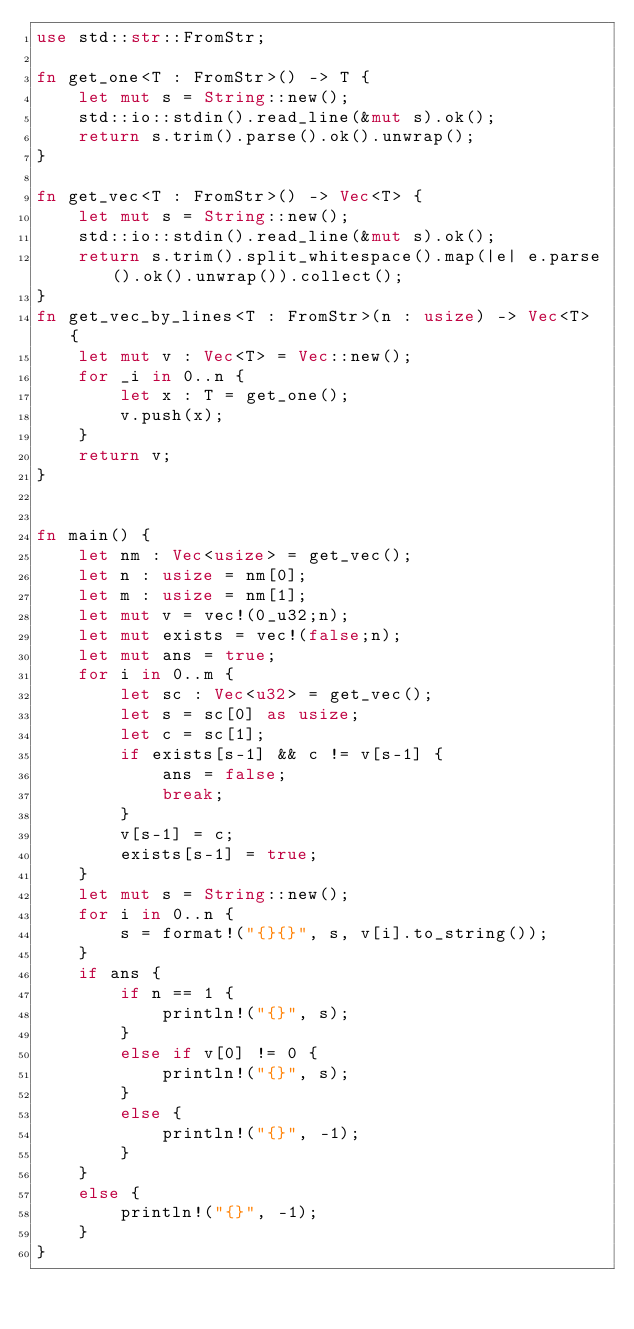Convert code to text. <code><loc_0><loc_0><loc_500><loc_500><_Rust_>use std::str::FromStr;

fn get_one<T : FromStr>() -> T {
    let mut s = String::new();
    std::io::stdin().read_line(&mut s).ok();
    return s.trim().parse().ok().unwrap();
}

fn get_vec<T : FromStr>() -> Vec<T> {
    let mut s = String::new();
    std::io::stdin().read_line(&mut s).ok();
    return s.trim().split_whitespace().map(|e| e.parse().ok().unwrap()).collect();
}
fn get_vec_by_lines<T : FromStr>(n : usize) -> Vec<T> {
    let mut v : Vec<T> = Vec::new();
    for _i in 0..n {
        let x : T = get_one();
        v.push(x);
    }
    return v;
}


fn main() {
    let nm : Vec<usize> = get_vec();
    let n : usize = nm[0];
    let m : usize = nm[1];
    let mut v = vec!(0_u32;n);
    let mut exists = vec!(false;n);
    let mut ans = true;
    for i in 0..m {
        let sc : Vec<u32> = get_vec();
        let s = sc[0] as usize;
        let c = sc[1];
        if exists[s-1] && c != v[s-1] {
            ans = false;
            break;
        }
        v[s-1] = c;
        exists[s-1] = true;
    }
    let mut s = String::new();
    for i in 0..n {
        s = format!("{}{}", s, v[i].to_string());
    }
    if ans {
        if n == 1 {
            println!("{}", s);
        }
        else if v[0] != 0 {
            println!("{}", s);
        }
        else {
            println!("{}", -1);
        }
    }
    else {
        println!("{}", -1);
    }
}
</code> 